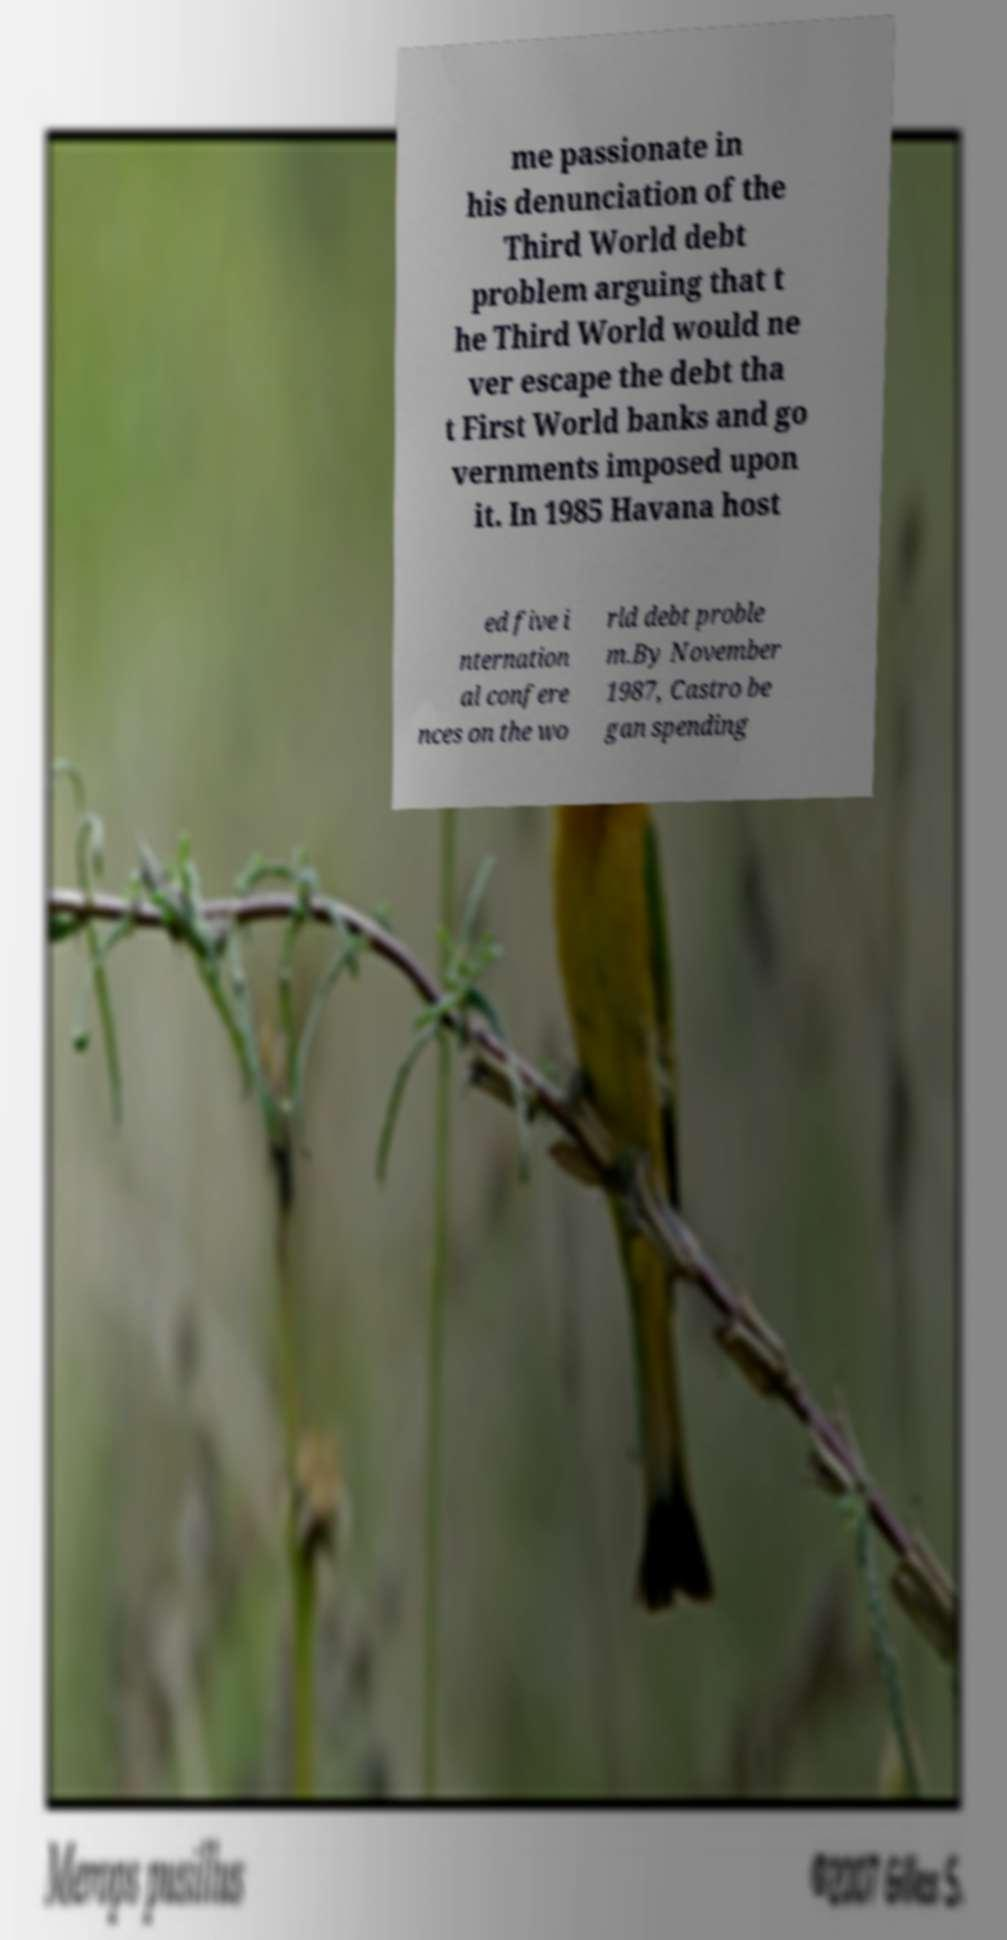There's text embedded in this image that I need extracted. Can you transcribe it verbatim? me passionate in his denunciation of the Third World debt problem arguing that t he Third World would ne ver escape the debt tha t First World banks and go vernments imposed upon it. In 1985 Havana host ed five i nternation al confere nces on the wo rld debt proble m.By November 1987, Castro be gan spending 